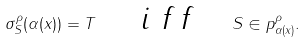Convert formula to latex. <formula><loc_0><loc_0><loc_500><loc_500>\sigma _ { S } ^ { \rho } ( \alpha ( x ) ) = T \quad \emph { i f f } \quad S \in p _ { \alpha ( x ) } ^ { \rho } .</formula> 